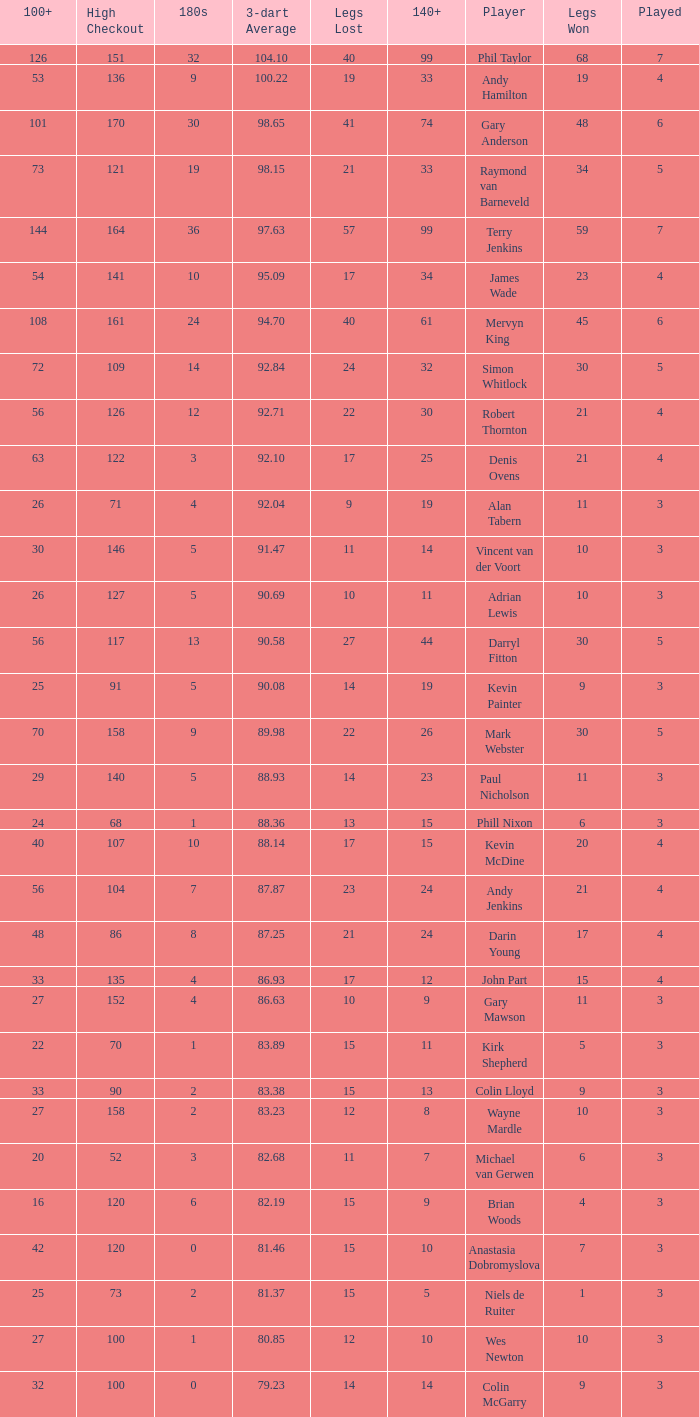What is the high checkout when Legs Won is smaller than 9, a 180s of 1, and a 3-dart Average larger than 88.36? None. 